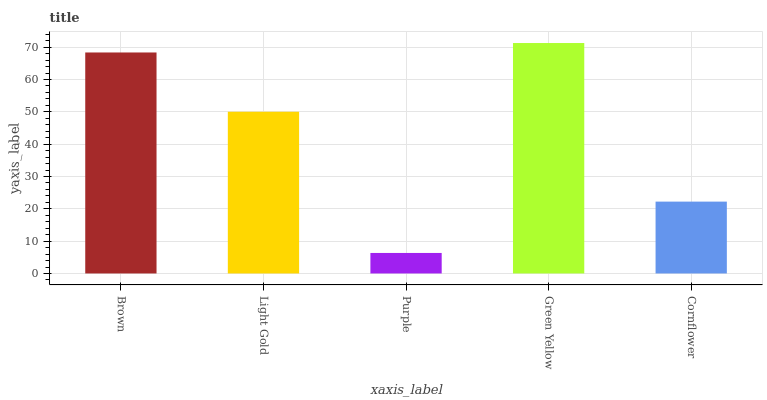Is Purple the minimum?
Answer yes or no. Yes. Is Green Yellow the maximum?
Answer yes or no. Yes. Is Light Gold the minimum?
Answer yes or no. No. Is Light Gold the maximum?
Answer yes or no. No. Is Brown greater than Light Gold?
Answer yes or no. Yes. Is Light Gold less than Brown?
Answer yes or no. Yes. Is Light Gold greater than Brown?
Answer yes or no. No. Is Brown less than Light Gold?
Answer yes or no. No. Is Light Gold the high median?
Answer yes or no. Yes. Is Light Gold the low median?
Answer yes or no. Yes. Is Brown the high median?
Answer yes or no. No. Is Green Yellow the low median?
Answer yes or no. No. 